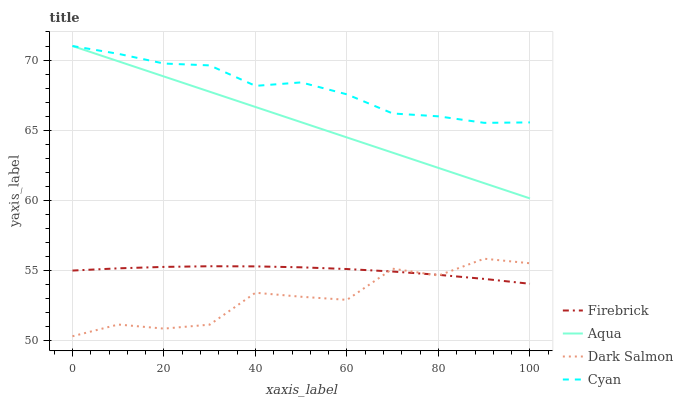Does Dark Salmon have the minimum area under the curve?
Answer yes or no. Yes. Does Cyan have the maximum area under the curve?
Answer yes or no. Yes. Does Firebrick have the minimum area under the curve?
Answer yes or no. No. Does Firebrick have the maximum area under the curve?
Answer yes or no. No. Is Aqua the smoothest?
Answer yes or no. Yes. Is Dark Salmon the roughest?
Answer yes or no. Yes. Is Firebrick the smoothest?
Answer yes or no. No. Is Firebrick the roughest?
Answer yes or no. No. Does Dark Salmon have the lowest value?
Answer yes or no. Yes. Does Firebrick have the lowest value?
Answer yes or no. No. Does Aqua have the highest value?
Answer yes or no. Yes. Does Firebrick have the highest value?
Answer yes or no. No. Is Firebrick less than Cyan?
Answer yes or no. Yes. Is Aqua greater than Dark Salmon?
Answer yes or no. Yes. Does Aqua intersect Cyan?
Answer yes or no. Yes. Is Aqua less than Cyan?
Answer yes or no. No. Is Aqua greater than Cyan?
Answer yes or no. No. Does Firebrick intersect Cyan?
Answer yes or no. No. 